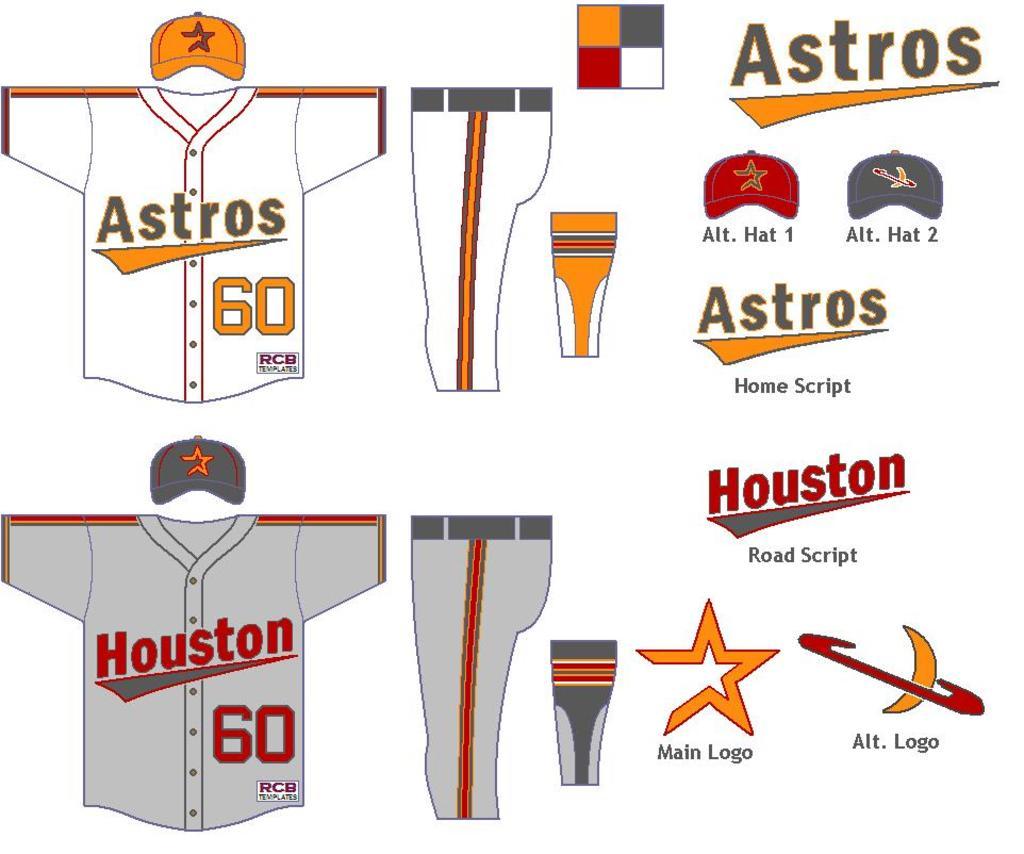What team is this?
Keep it short and to the point. Astros. 